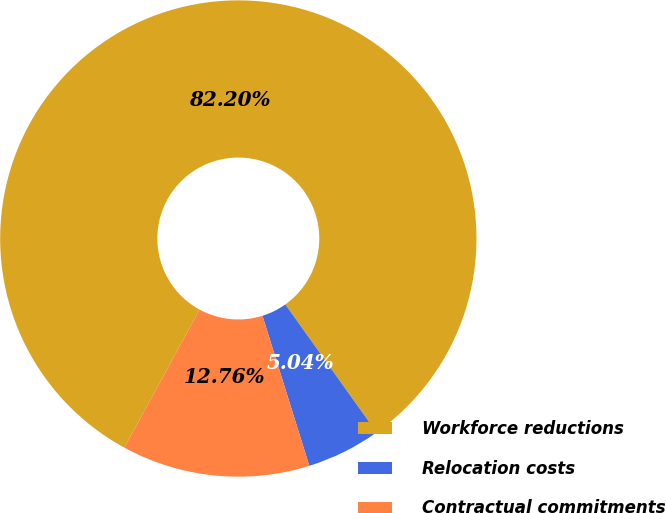<chart> <loc_0><loc_0><loc_500><loc_500><pie_chart><fcel>Workforce reductions<fcel>Relocation costs<fcel>Contractual commitments<nl><fcel>82.2%<fcel>5.04%<fcel>12.76%<nl></chart> 